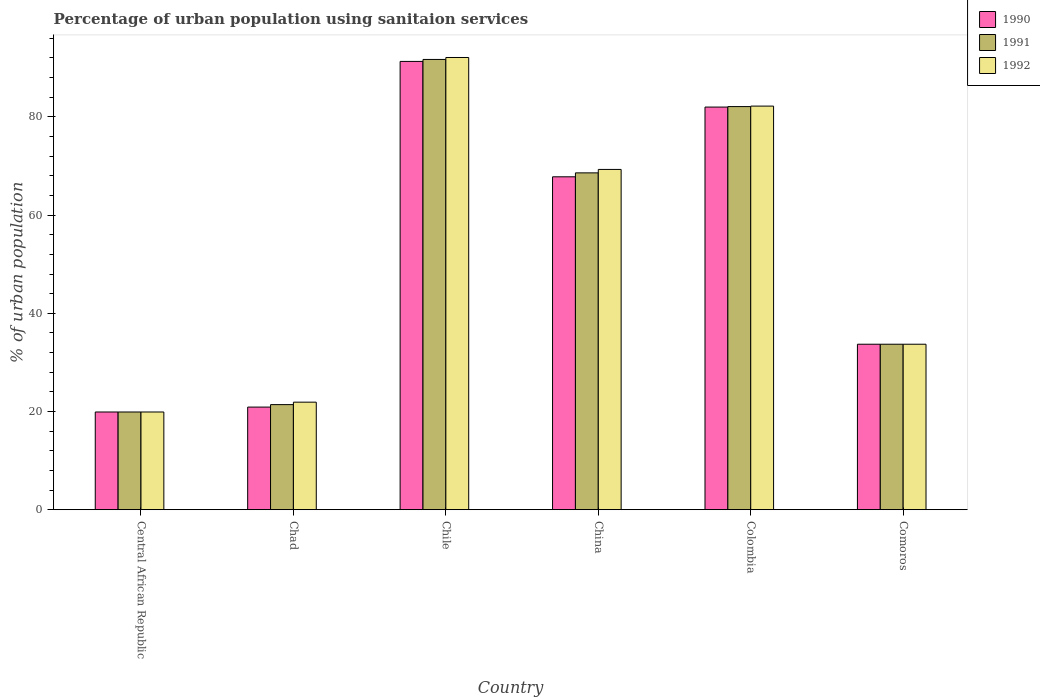How many different coloured bars are there?
Ensure brevity in your answer.  3. Are the number of bars per tick equal to the number of legend labels?
Ensure brevity in your answer.  Yes. How many bars are there on the 5th tick from the left?
Ensure brevity in your answer.  3. In how many cases, is the number of bars for a given country not equal to the number of legend labels?
Ensure brevity in your answer.  0. What is the percentage of urban population using sanitaion services in 1992 in China?
Keep it short and to the point. 69.3. Across all countries, what is the maximum percentage of urban population using sanitaion services in 1992?
Make the answer very short. 92.1. In which country was the percentage of urban population using sanitaion services in 1991 maximum?
Ensure brevity in your answer.  Chile. In which country was the percentage of urban population using sanitaion services in 1990 minimum?
Your response must be concise. Central African Republic. What is the total percentage of urban population using sanitaion services in 1991 in the graph?
Give a very brief answer. 317.4. What is the difference between the percentage of urban population using sanitaion services in 1991 in China and that in Comoros?
Offer a very short reply. 34.9. What is the difference between the percentage of urban population using sanitaion services in 1990 in Chile and the percentage of urban population using sanitaion services in 1992 in Chad?
Ensure brevity in your answer.  69.4. What is the average percentage of urban population using sanitaion services in 1992 per country?
Provide a short and direct response. 53.18. What is the difference between the percentage of urban population using sanitaion services of/in 1992 and percentage of urban population using sanitaion services of/in 1991 in Comoros?
Keep it short and to the point. 0. In how many countries, is the percentage of urban population using sanitaion services in 1991 greater than 80 %?
Offer a very short reply. 2. What is the ratio of the percentage of urban population using sanitaion services in 1992 in Chile to that in Comoros?
Keep it short and to the point. 2.73. Is the percentage of urban population using sanitaion services in 1992 in Chad less than that in Colombia?
Ensure brevity in your answer.  Yes. What is the difference between the highest and the second highest percentage of urban population using sanitaion services in 1990?
Your response must be concise. -14.2. What is the difference between the highest and the lowest percentage of urban population using sanitaion services in 1991?
Your answer should be very brief. 71.8. Is the sum of the percentage of urban population using sanitaion services in 1991 in Central African Republic and Chad greater than the maximum percentage of urban population using sanitaion services in 1990 across all countries?
Your response must be concise. No. What does the 1st bar from the left in Chad represents?
Your response must be concise. 1990. What is the difference between two consecutive major ticks on the Y-axis?
Ensure brevity in your answer.  20. How many legend labels are there?
Give a very brief answer. 3. How are the legend labels stacked?
Keep it short and to the point. Vertical. What is the title of the graph?
Keep it short and to the point. Percentage of urban population using sanitaion services. Does "1982" appear as one of the legend labels in the graph?
Make the answer very short. No. What is the label or title of the Y-axis?
Keep it short and to the point. % of urban population. What is the % of urban population of 1990 in Chad?
Your answer should be very brief. 20.9. What is the % of urban population in 1991 in Chad?
Offer a very short reply. 21.4. What is the % of urban population of 1992 in Chad?
Provide a short and direct response. 21.9. What is the % of urban population of 1990 in Chile?
Ensure brevity in your answer.  91.3. What is the % of urban population in 1991 in Chile?
Offer a terse response. 91.7. What is the % of urban population in 1992 in Chile?
Ensure brevity in your answer.  92.1. What is the % of urban population in 1990 in China?
Give a very brief answer. 67.8. What is the % of urban population of 1991 in China?
Make the answer very short. 68.6. What is the % of urban population in 1992 in China?
Make the answer very short. 69.3. What is the % of urban population of 1991 in Colombia?
Your answer should be compact. 82.1. What is the % of urban population in 1992 in Colombia?
Your answer should be very brief. 82.2. What is the % of urban population of 1990 in Comoros?
Your answer should be very brief. 33.7. What is the % of urban population in 1991 in Comoros?
Provide a succinct answer. 33.7. What is the % of urban population of 1992 in Comoros?
Your answer should be very brief. 33.7. Across all countries, what is the maximum % of urban population in 1990?
Ensure brevity in your answer.  91.3. Across all countries, what is the maximum % of urban population of 1991?
Keep it short and to the point. 91.7. Across all countries, what is the maximum % of urban population of 1992?
Give a very brief answer. 92.1. What is the total % of urban population of 1990 in the graph?
Ensure brevity in your answer.  315.6. What is the total % of urban population of 1991 in the graph?
Keep it short and to the point. 317.4. What is the total % of urban population in 1992 in the graph?
Keep it short and to the point. 319.1. What is the difference between the % of urban population of 1990 in Central African Republic and that in Chad?
Offer a very short reply. -1. What is the difference between the % of urban population of 1990 in Central African Republic and that in Chile?
Offer a very short reply. -71.4. What is the difference between the % of urban population of 1991 in Central African Republic and that in Chile?
Give a very brief answer. -71.8. What is the difference between the % of urban population of 1992 in Central African Republic and that in Chile?
Keep it short and to the point. -72.2. What is the difference between the % of urban population in 1990 in Central African Republic and that in China?
Provide a short and direct response. -47.9. What is the difference between the % of urban population in 1991 in Central African Republic and that in China?
Provide a short and direct response. -48.7. What is the difference between the % of urban population in 1992 in Central African Republic and that in China?
Give a very brief answer. -49.4. What is the difference between the % of urban population in 1990 in Central African Republic and that in Colombia?
Your response must be concise. -62.1. What is the difference between the % of urban population of 1991 in Central African Republic and that in Colombia?
Your response must be concise. -62.2. What is the difference between the % of urban population of 1992 in Central African Republic and that in Colombia?
Your answer should be compact. -62.3. What is the difference between the % of urban population of 1991 in Central African Republic and that in Comoros?
Offer a very short reply. -13.8. What is the difference between the % of urban population in 1992 in Central African Republic and that in Comoros?
Provide a succinct answer. -13.8. What is the difference between the % of urban population in 1990 in Chad and that in Chile?
Give a very brief answer. -70.4. What is the difference between the % of urban population in 1991 in Chad and that in Chile?
Provide a short and direct response. -70.3. What is the difference between the % of urban population of 1992 in Chad and that in Chile?
Keep it short and to the point. -70.2. What is the difference between the % of urban population in 1990 in Chad and that in China?
Keep it short and to the point. -46.9. What is the difference between the % of urban population of 1991 in Chad and that in China?
Provide a short and direct response. -47.2. What is the difference between the % of urban population of 1992 in Chad and that in China?
Ensure brevity in your answer.  -47.4. What is the difference between the % of urban population in 1990 in Chad and that in Colombia?
Your response must be concise. -61.1. What is the difference between the % of urban population in 1991 in Chad and that in Colombia?
Provide a short and direct response. -60.7. What is the difference between the % of urban population of 1992 in Chad and that in Colombia?
Offer a terse response. -60.3. What is the difference between the % of urban population of 1991 in Chad and that in Comoros?
Your answer should be compact. -12.3. What is the difference between the % of urban population of 1992 in Chad and that in Comoros?
Your answer should be compact. -11.8. What is the difference between the % of urban population in 1991 in Chile and that in China?
Give a very brief answer. 23.1. What is the difference between the % of urban population of 1992 in Chile and that in China?
Offer a terse response. 22.8. What is the difference between the % of urban population in 1991 in Chile and that in Colombia?
Make the answer very short. 9.6. What is the difference between the % of urban population in 1992 in Chile and that in Colombia?
Offer a terse response. 9.9. What is the difference between the % of urban population in 1990 in Chile and that in Comoros?
Ensure brevity in your answer.  57.6. What is the difference between the % of urban population of 1992 in Chile and that in Comoros?
Your answer should be compact. 58.4. What is the difference between the % of urban population of 1991 in China and that in Colombia?
Make the answer very short. -13.5. What is the difference between the % of urban population in 1990 in China and that in Comoros?
Your response must be concise. 34.1. What is the difference between the % of urban population in 1991 in China and that in Comoros?
Your answer should be very brief. 34.9. What is the difference between the % of urban population of 1992 in China and that in Comoros?
Offer a terse response. 35.6. What is the difference between the % of urban population in 1990 in Colombia and that in Comoros?
Offer a very short reply. 48.3. What is the difference between the % of urban population in 1991 in Colombia and that in Comoros?
Your response must be concise. 48.4. What is the difference between the % of urban population in 1992 in Colombia and that in Comoros?
Make the answer very short. 48.5. What is the difference between the % of urban population in 1990 in Central African Republic and the % of urban population in 1992 in Chad?
Keep it short and to the point. -2. What is the difference between the % of urban population in 1991 in Central African Republic and the % of urban population in 1992 in Chad?
Provide a succinct answer. -2. What is the difference between the % of urban population of 1990 in Central African Republic and the % of urban population of 1991 in Chile?
Provide a short and direct response. -71.8. What is the difference between the % of urban population of 1990 in Central African Republic and the % of urban population of 1992 in Chile?
Your response must be concise. -72.2. What is the difference between the % of urban population in 1991 in Central African Republic and the % of urban population in 1992 in Chile?
Keep it short and to the point. -72.2. What is the difference between the % of urban population of 1990 in Central African Republic and the % of urban population of 1991 in China?
Ensure brevity in your answer.  -48.7. What is the difference between the % of urban population of 1990 in Central African Republic and the % of urban population of 1992 in China?
Your answer should be very brief. -49.4. What is the difference between the % of urban population in 1991 in Central African Republic and the % of urban population in 1992 in China?
Your response must be concise. -49.4. What is the difference between the % of urban population in 1990 in Central African Republic and the % of urban population in 1991 in Colombia?
Give a very brief answer. -62.2. What is the difference between the % of urban population of 1990 in Central African Republic and the % of urban population of 1992 in Colombia?
Your answer should be compact. -62.3. What is the difference between the % of urban population of 1991 in Central African Republic and the % of urban population of 1992 in Colombia?
Your response must be concise. -62.3. What is the difference between the % of urban population in 1990 in Central African Republic and the % of urban population in 1991 in Comoros?
Your response must be concise. -13.8. What is the difference between the % of urban population of 1990 in Central African Republic and the % of urban population of 1992 in Comoros?
Keep it short and to the point. -13.8. What is the difference between the % of urban population of 1990 in Chad and the % of urban population of 1991 in Chile?
Keep it short and to the point. -70.8. What is the difference between the % of urban population in 1990 in Chad and the % of urban population in 1992 in Chile?
Your answer should be compact. -71.2. What is the difference between the % of urban population of 1991 in Chad and the % of urban population of 1992 in Chile?
Make the answer very short. -70.7. What is the difference between the % of urban population in 1990 in Chad and the % of urban population in 1991 in China?
Your answer should be compact. -47.7. What is the difference between the % of urban population in 1990 in Chad and the % of urban population in 1992 in China?
Provide a succinct answer. -48.4. What is the difference between the % of urban population in 1991 in Chad and the % of urban population in 1992 in China?
Offer a terse response. -47.9. What is the difference between the % of urban population in 1990 in Chad and the % of urban population in 1991 in Colombia?
Give a very brief answer. -61.2. What is the difference between the % of urban population of 1990 in Chad and the % of urban population of 1992 in Colombia?
Keep it short and to the point. -61.3. What is the difference between the % of urban population of 1991 in Chad and the % of urban population of 1992 in Colombia?
Your response must be concise. -60.8. What is the difference between the % of urban population in 1990 in Chad and the % of urban population in 1991 in Comoros?
Ensure brevity in your answer.  -12.8. What is the difference between the % of urban population in 1990 in Chad and the % of urban population in 1992 in Comoros?
Your answer should be very brief. -12.8. What is the difference between the % of urban population in 1991 in Chad and the % of urban population in 1992 in Comoros?
Give a very brief answer. -12.3. What is the difference between the % of urban population in 1990 in Chile and the % of urban population in 1991 in China?
Keep it short and to the point. 22.7. What is the difference between the % of urban population of 1991 in Chile and the % of urban population of 1992 in China?
Your answer should be compact. 22.4. What is the difference between the % of urban population of 1990 in Chile and the % of urban population of 1991 in Colombia?
Your response must be concise. 9.2. What is the difference between the % of urban population of 1990 in Chile and the % of urban population of 1992 in Colombia?
Your answer should be compact. 9.1. What is the difference between the % of urban population of 1991 in Chile and the % of urban population of 1992 in Colombia?
Offer a terse response. 9.5. What is the difference between the % of urban population in 1990 in Chile and the % of urban population in 1991 in Comoros?
Provide a short and direct response. 57.6. What is the difference between the % of urban population in 1990 in Chile and the % of urban population in 1992 in Comoros?
Provide a succinct answer. 57.6. What is the difference between the % of urban population in 1991 in Chile and the % of urban population in 1992 in Comoros?
Keep it short and to the point. 58. What is the difference between the % of urban population in 1990 in China and the % of urban population in 1991 in Colombia?
Provide a short and direct response. -14.3. What is the difference between the % of urban population of 1990 in China and the % of urban population of 1992 in Colombia?
Provide a short and direct response. -14.4. What is the difference between the % of urban population in 1991 in China and the % of urban population in 1992 in Colombia?
Your response must be concise. -13.6. What is the difference between the % of urban population of 1990 in China and the % of urban population of 1991 in Comoros?
Make the answer very short. 34.1. What is the difference between the % of urban population of 1990 in China and the % of urban population of 1992 in Comoros?
Give a very brief answer. 34.1. What is the difference between the % of urban population of 1991 in China and the % of urban population of 1992 in Comoros?
Provide a succinct answer. 34.9. What is the difference between the % of urban population of 1990 in Colombia and the % of urban population of 1991 in Comoros?
Your answer should be very brief. 48.3. What is the difference between the % of urban population of 1990 in Colombia and the % of urban population of 1992 in Comoros?
Your response must be concise. 48.3. What is the difference between the % of urban population of 1991 in Colombia and the % of urban population of 1992 in Comoros?
Make the answer very short. 48.4. What is the average % of urban population in 1990 per country?
Ensure brevity in your answer.  52.6. What is the average % of urban population of 1991 per country?
Your answer should be compact. 52.9. What is the average % of urban population of 1992 per country?
Give a very brief answer. 53.18. What is the difference between the % of urban population in 1990 and % of urban population in 1992 in Central African Republic?
Your answer should be very brief. 0. What is the difference between the % of urban population in 1991 and % of urban population in 1992 in Central African Republic?
Offer a very short reply. 0. What is the difference between the % of urban population of 1990 and % of urban population of 1991 in Chile?
Give a very brief answer. -0.4. What is the difference between the % of urban population of 1990 and % of urban population of 1992 in Chile?
Your response must be concise. -0.8. What is the difference between the % of urban population in 1990 and % of urban population in 1991 in China?
Offer a very short reply. -0.8. What is the difference between the % of urban population in 1990 and % of urban population in 1992 in Comoros?
Your answer should be very brief. 0. What is the ratio of the % of urban population of 1990 in Central African Republic to that in Chad?
Ensure brevity in your answer.  0.95. What is the ratio of the % of urban population of 1991 in Central African Republic to that in Chad?
Your answer should be very brief. 0.93. What is the ratio of the % of urban population in 1992 in Central African Republic to that in Chad?
Your answer should be very brief. 0.91. What is the ratio of the % of urban population in 1990 in Central African Republic to that in Chile?
Provide a short and direct response. 0.22. What is the ratio of the % of urban population in 1991 in Central African Republic to that in Chile?
Ensure brevity in your answer.  0.22. What is the ratio of the % of urban population in 1992 in Central African Republic to that in Chile?
Your answer should be very brief. 0.22. What is the ratio of the % of urban population in 1990 in Central African Republic to that in China?
Your response must be concise. 0.29. What is the ratio of the % of urban population in 1991 in Central African Republic to that in China?
Offer a terse response. 0.29. What is the ratio of the % of urban population of 1992 in Central African Republic to that in China?
Offer a terse response. 0.29. What is the ratio of the % of urban population in 1990 in Central African Republic to that in Colombia?
Keep it short and to the point. 0.24. What is the ratio of the % of urban population of 1991 in Central African Republic to that in Colombia?
Your answer should be very brief. 0.24. What is the ratio of the % of urban population in 1992 in Central African Republic to that in Colombia?
Your answer should be very brief. 0.24. What is the ratio of the % of urban population of 1990 in Central African Republic to that in Comoros?
Offer a very short reply. 0.59. What is the ratio of the % of urban population in 1991 in Central African Republic to that in Comoros?
Offer a very short reply. 0.59. What is the ratio of the % of urban population of 1992 in Central African Republic to that in Comoros?
Provide a succinct answer. 0.59. What is the ratio of the % of urban population of 1990 in Chad to that in Chile?
Your answer should be very brief. 0.23. What is the ratio of the % of urban population in 1991 in Chad to that in Chile?
Make the answer very short. 0.23. What is the ratio of the % of urban population in 1992 in Chad to that in Chile?
Ensure brevity in your answer.  0.24. What is the ratio of the % of urban population of 1990 in Chad to that in China?
Ensure brevity in your answer.  0.31. What is the ratio of the % of urban population of 1991 in Chad to that in China?
Ensure brevity in your answer.  0.31. What is the ratio of the % of urban population in 1992 in Chad to that in China?
Your response must be concise. 0.32. What is the ratio of the % of urban population of 1990 in Chad to that in Colombia?
Ensure brevity in your answer.  0.25. What is the ratio of the % of urban population in 1991 in Chad to that in Colombia?
Your response must be concise. 0.26. What is the ratio of the % of urban population of 1992 in Chad to that in Colombia?
Your answer should be compact. 0.27. What is the ratio of the % of urban population of 1990 in Chad to that in Comoros?
Offer a terse response. 0.62. What is the ratio of the % of urban population in 1991 in Chad to that in Comoros?
Offer a very short reply. 0.64. What is the ratio of the % of urban population in 1992 in Chad to that in Comoros?
Your answer should be compact. 0.65. What is the ratio of the % of urban population of 1990 in Chile to that in China?
Ensure brevity in your answer.  1.35. What is the ratio of the % of urban population of 1991 in Chile to that in China?
Ensure brevity in your answer.  1.34. What is the ratio of the % of urban population of 1992 in Chile to that in China?
Offer a terse response. 1.33. What is the ratio of the % of urban population of 1990 in Chile to that in Colombia?
Offer a very short reply. 1.11. What is the ratio of the % of urban population of 1991 in Chile to that in Colombia?
Provide a short and direct response. 1.12. What is the ratio of the % of urban population of 1992 in Chile to that in Colombia?
Provide a succinct answer. 1.12. What is the ratio of the % of urban population in 1990 in Chile to that in Comoros?
Your answer should be very brief. 2.71. What is the ratio of the % of urban population in 1991 in Chile to that in Comoros?
Offer a terse response. 2.72. What is the ratio of the % of urban population of 1992 in Chile to that in Comoros?
Offer a very short reply. 2.73. What is the ratio of the % of urban population in 1990 in China to that in Colombia?
Offer a terse response. 0.83. What is the ratio of the % of urban population of 1991 in China to that in Colombia?
Provide a short and direct response. 0.84. What is the ratio of the % of urban population of 1992 in China to that in Colombia?
Offer a terse response. 0.84. What is the ratio of the % of urban population in 1990 in China to that in Comoros?
Keep it short and to the point. 2.01. What is the ratio of the % of urban population in 1991 in China to that in Comoros?
Your answer should be compact. 2.04. What is the ratio of the % of urban population in 1992 in China to that in Comoros?
Provide a short and direct response. 2.06. What is the ratio of the % of urban population in 1990 in Colombia to that in Comoros?
Offer a terse response. 2.43. What is the ratio of the % of urban population in 1991 in Colombia to that in Comoros?
Offer a terse response. 2.44. What is the ratio of the % of urban population of 1992 in Colombia to that in Comoros?
Your response must be concise. 2.44. What is the difference between the highest and the second highest % of urban population in 1991?
Your response must be concise. 9.6. What is the difference between the highest and the lowest % of urban population in 1990?
Your answer should be compact. 71.4. What is the difference between the highest and the lowest % of urban population in 1991?
Make the answer very short. 71.8. What is the difference between the highest and the lowest % of urban population of 1992?
Your answer should be very brief. 72.2. 